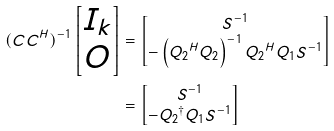Convert formula to latex. <formula><loc_0><loc_0><loc_500><loc_500>( C C ^ { H } ) ^ { - 1 } \begin{bmatrix} I _ { k } \\ O \end{bmatrix} & = \begin{bmatrix} S ^ { - 1 } \\ - \left ( { Q _ { 2 } } ^ { H } Q _ { 2 } \right ) ^ { - 1 } { Q _ { 2 } } ^ { H } Q _ { 1 } S ^ { - 1 } \end{bmatrix} \\ & = \begin{bmatrix} S ^ { - 1 } \\ - { Q _ { 2 } } ^ { \dag } { Q _ { 1 } } S ^ { - 1 } \end{bmatrix}</formula> 